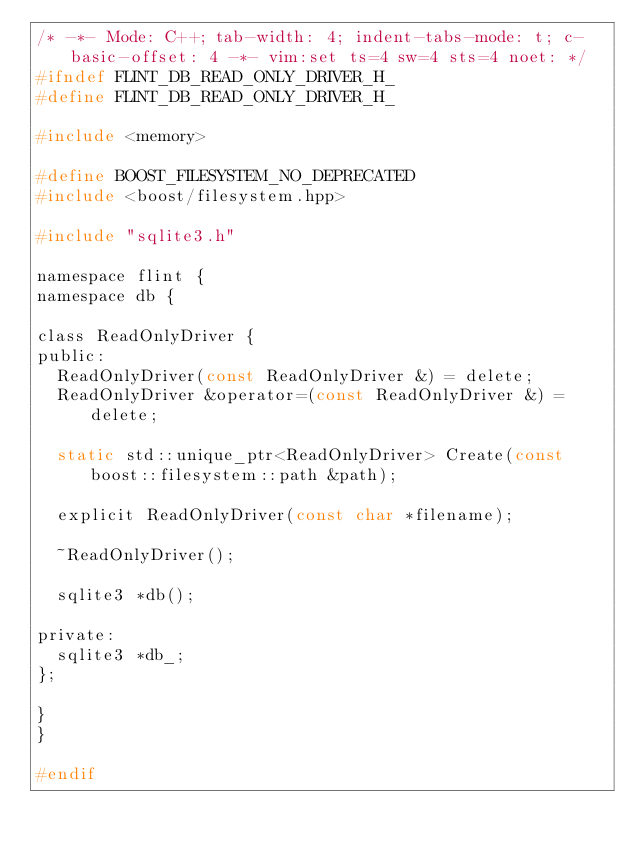<code> <loc_0><loc_0><loc_500><loc_500><_C_>/* -*- Mode: C++; tab-width: 4; indent-tabs-mode: t; c-basic-offset: 4 -*- vim:set ts=4 sw=4 sts=4 noet: */
#ifndef FLINT_DB_READ_ONLY_DRIVER_H_
#define FLINT_DB_READ_ONLY_DRIVER_H_

#include <memory>

#define BOOST_FILESYSTEM_NO_DEPRECATED
#include <boost/filesystem.hpp>

#include "sqlite3.h"

namespace flint {
namespace db {

class ReadOnlyDriver {
public:
	ReadOnlyDriver(const ReadOnlyDriver &) = delete;
	ReadOnlyDriver &operator=(const ReadOnlyDriver &) = delete;

	static std::unique_ptr<ReadOnlyDriver> Create(const boost::filesystem::path &path);

	explicit ReadOnlyDriver(const char *filename);

	~ReadOnlyDriver();

	sqlite3 *db();

private:
	sqlite3 *db_;
};

}
}

#endif
</code> 